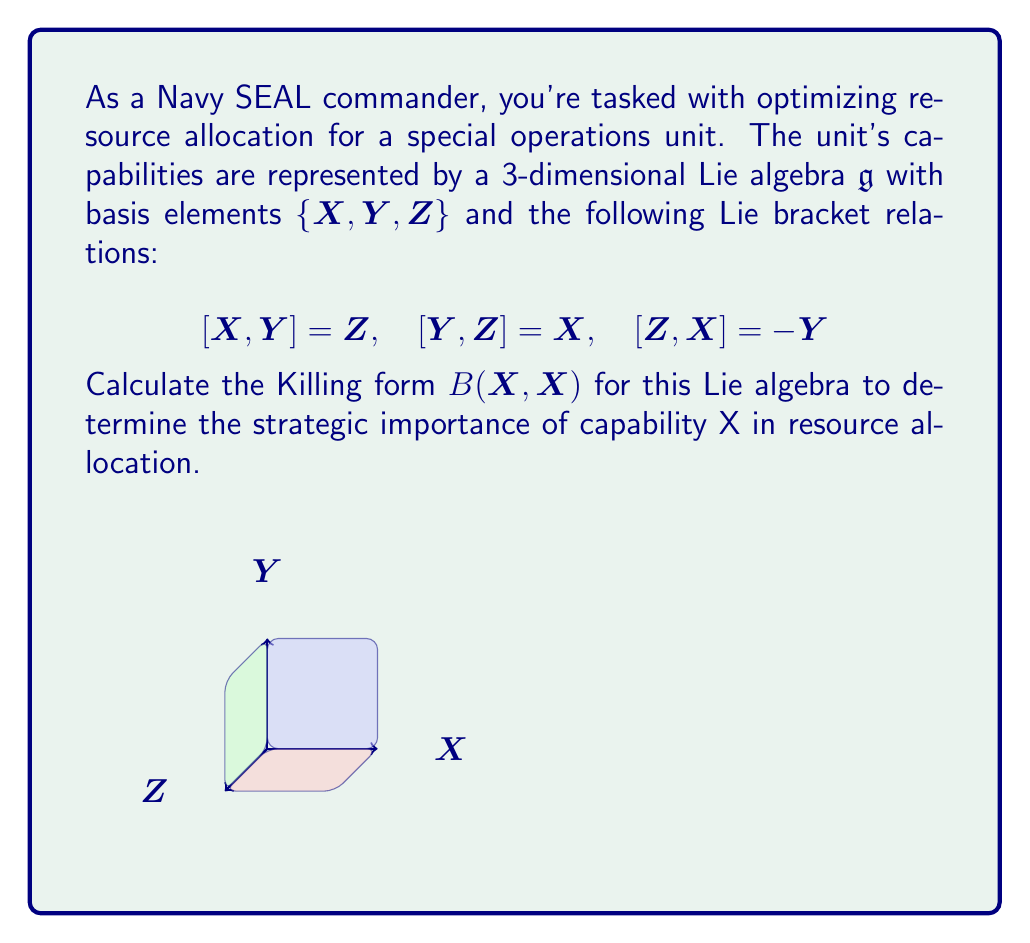What is the answer to this math problem? Let's approach this step-by-step:

1) The Killing form $B(X,Y)$ for a Lie algebra is defined as:

   $$B(X,Y) = \text{tr}(\text{ad}(X) \circ \text{ad}(Y))$$

   where $\text{ad}(X)$ is the adjoint representation of $X$.

2) To calculate $B(X,X)$, we need to find $\text{ad}(X)$ first. We can do this by applying the adjoint action to each basis element:

   $$\text{ad}(X)(X) = 0$$
   $$\text{ad}(X)(Y) = [X,Y] = Z$$
   $$\text{ad}(X)(Z) = [X,Z] = Y$$

3) This gives us the matrix representation of $\text{ad}(X)$:

   $$\text{ad}(X) = \begin{pmatrix}
   0 & 0 & 0 \\
   0 & 0 & -1 \\
   0 & 1 & 0
   \end{pmatrix}$$

4) Now, we need to calculate $\text{ad}(X) \circ \text{ad}(X)$:

   $$\text{ad}(X) \circ \text{ad}(X) = \begin{pmatrix}
   0 & 0 & 0 \\
   0 & -1 & 0 \\
   0 & 0 & -1
   \end{pmatrix}$$

5) The Killing form $B(X,X)$ is the trace of this matrix:

   $$B(X,X) = \text{tr}(\text{ad}(X) \circ \text{ad}(X)) = 0 + (-1) + (-1) = -2$$

6) In the context of military resource allocation, a non-zero Killing form indicates that capability X has strategic importance. The negative value suggests that increasing resources in this capability might have a stabilizing effect on the overall strategy.
Answer: $B(X,X) = -2$ 